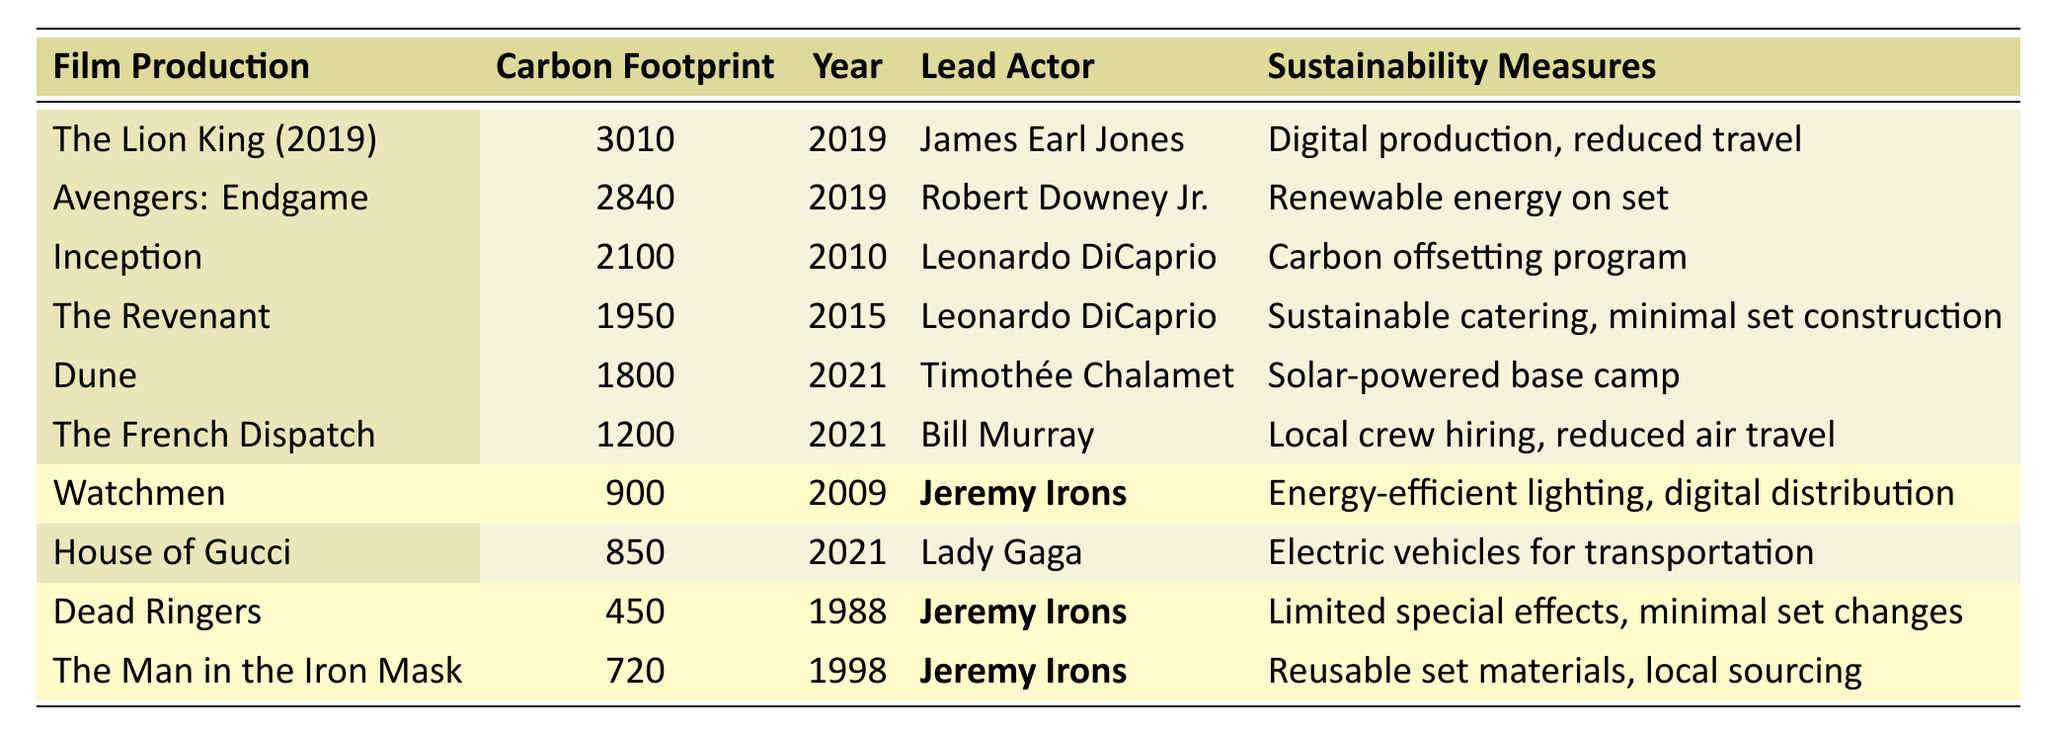What is the carbon footprint of "The Lion King (2019)"? The carbon footprint for "The Lion King (2019)" is listed in the table as 3010 tonnes CO2e.
Answer: 3010 tonnes CO2e Which film has the lowest carbon footprint? By comparing the carbon footprints from the table, "Dead Ringers" has the lowest carbon footprint at 450 tonnes CO2e.
Answer: Dead Ringers How many tonnes of CO2e did "Avengers: Endgame" produce? The table shows that "Avengers: Endgame" produced 2840 tonnes CO2e.
Answer: 2840 tonnes CO2e What sustainability measure was used in "Dune"? The table indicates that "Dune" utilized a solar-powered base camp as its sustainability measure.
Answer: Solar-powered base camp Is "Jeremy Irons" the lead actor in "House of Gucci"? The table shows that the lead actor in "House of Gucci" is actually Lady Gaga, not Jeremy Irons.
Answer: No What is the average carbon footprint of the films starring Jeremy Irons? The carbon footprints of the films starring Jeremy Irons are 900, 450, and 720 tonnes CO2e. Adding these gives 2070, and there are 3 films, so the average is 2070/3 = 690 tonnes CO2e.
Answer: 690 tonnes CO2e Which film released in 2021 has a higher carbon footprint: "Dune" or "The French Dispatch"? "Dune" has a carbon footprint of 1800 tonnes CO2e while "The French Dispatch" has 1200 tonnes CO2e. Therefore, "Dune" has a higher carbon footprint.
Answer: Dune What was the total carbon footprint of the films featuring Leonardo DiCaprio? The total carbon footprint for the films with Leonardo DiCaprio is from "Inception" (2100) and "The Revenant" (1950), which adds up to 2100 + 1950 = 4050 tonnes CO2e.
Answer: 4050 tonnes CO2e Did any of the films produce more than 2500 tonnes of CO2e? Yes, both "The Lion King (2019)" and "Avengers: Endgame" produced more than 2500 tonnes CO2e, as indicated in the table.
Answer: Yes How many films listed in the table utilized local crew hiring as a sustainability measure? The table indicates that only "The French Dispatch" uses local crew hiring as a sustainability measure. Therefore, the answer is one film.
Answer: One film 